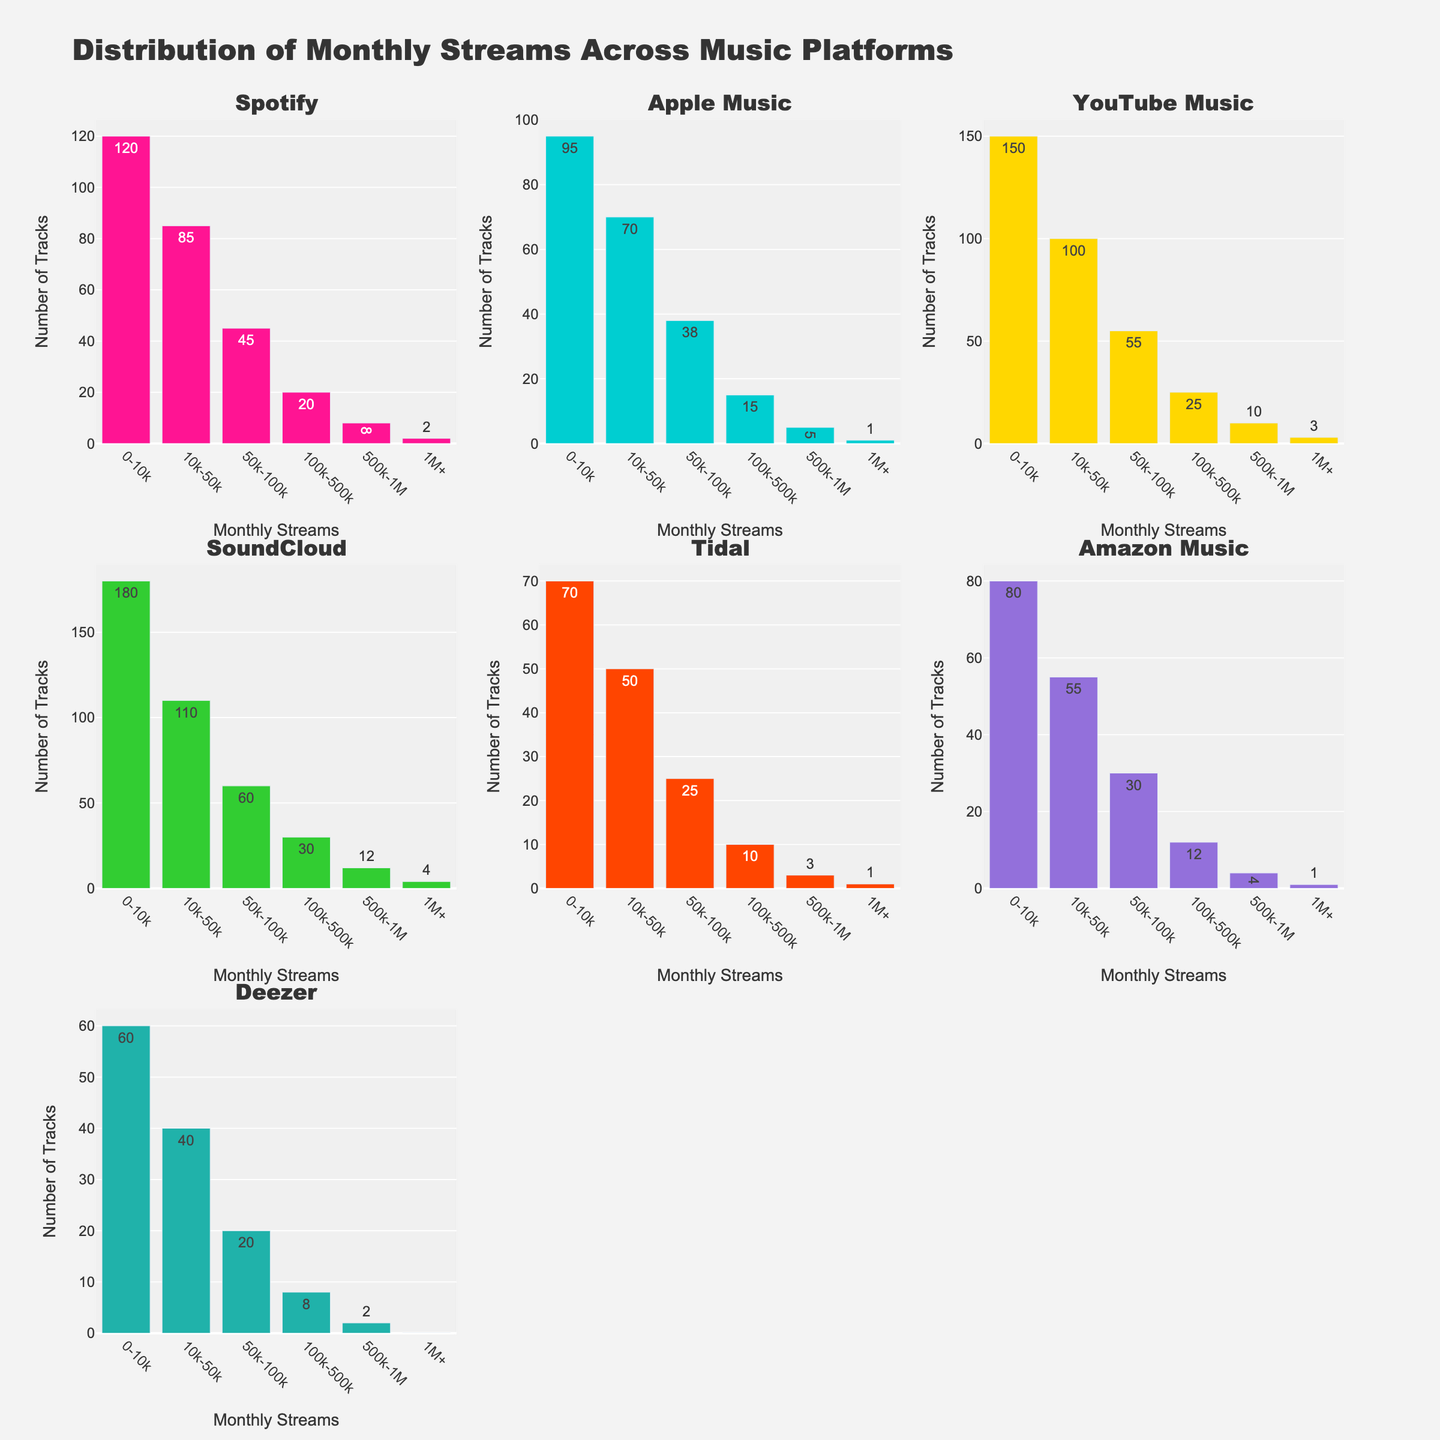what's the title of the figure? The title is displayed at the top of the figure in large font. It reads as "Distribution of Monthly Streams Across Music Platforms"
Answer: Distribution of Monthly Streams Across Music Platforms Which platform has the highest number of tracks in the '0-10k' streams category? By looking at the heights of the bars in the '0-10k' streams category, SoundCloud has the highest bar with 180 tracks.
Answer: SoundCloud What is the total number of tracks in the '50k-100k' streams category across all platforms? Add up the heights of the bars in the '50k-100k' streams category for all platforms: 45 (Spotify) + 38 (Apple Music) + 55 (YouTube Music) + 60 (SoundCloud) + 25 (Tidal) + 30 (Amazon Music) + 20 (Deezer) = 273
Answer: 273 Which two platforms have the same number of tracks in the '1M+' streams category? By comparing bars in the '1M+' category, Apple Music and Tidal both have 1 track.
Answer: Apple Music and Tidal How many platforms have more than 10 tracks in the '500k-1M' streams category? By checking the heights of the bars in the category '500k-1M', SoundCloud (12) and YouTube Music (10) have more than 10 tracks.
Answer: 2 What’s the average number of tracks in the '10k-50k' streams category across all platforms? Add up the heights of the bars in the '10k-50k' streams category and divide by the number of platforms: (85 (Spotify) + 70 (Apple Music) + 100 (YouTube Music) + 110 (SoundCloud) + 50 (Tidal) + 55 (Amazon Music) + 40 (Deezer)) / 7 = 510 / 7 ≈ 72.86
Answer: ~72.86 Which platform has the lowest number of tracks in the '0-10k' streams category? By looking at the heights of the bars in the '0-10k' streams category, Deezer has the lowest bar with 60 tracks.
Answer: Deezer What’s the difference in the number of tracks in the '100k-500k' streams category between YouTube Music and Spotify? Subtract Spotify's bar from YouTube Music's bar in the '100k-500k' streams category: 25 (YouTube Music) - 20 (Spotify) = 5
Answer: 5 Which platform has more tracks in the '1M+' streams category, Amazon Music or Deezer? Comparing the bars in the '1M+' streams category, Amazon Music has 1 track while Deezer has 0.
Answer: Amazon Music 